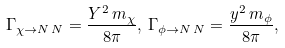<formula> <loc_0><loc_0><loc_500><loc_500>\Gamma _ { \chi \rightarrow N \, N } = \frac { Y ^ { 2 } \, m _ { \chi } } { 8 \pi } , \, \Gamma _ { \phi \rightarrow N \, N } = \frac { y ^ { 2 } \, m _ { \phi } } { 8 \pi } ,</formula> 